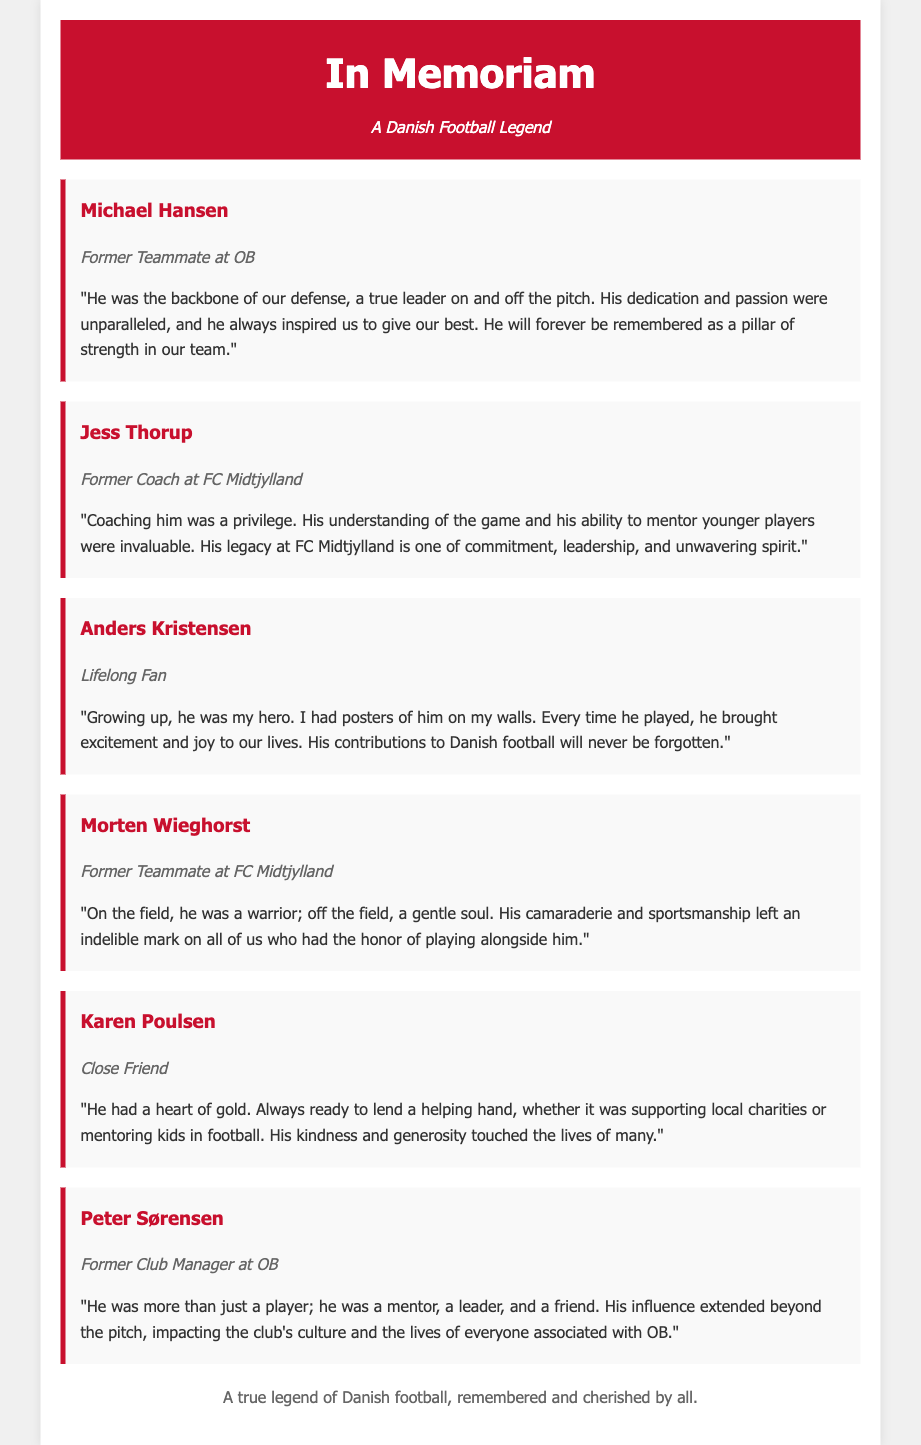What is the title of the document? The title appears in the header of the document and summarizes the tribute being made.
Answer: In Memoriam: A Danish Football Legend Who is quoted as a former teammate at OB? This information is found in the tributes section, identifying the individuals and their associations.
Answer: Michael Hansen What was Jess Thorup's role? The document specifies roles associated with each tribute, indicating who they were to the deceased.
Answer: Former Coach at FC Midtjylland Which friend described the deceased's heart as "of gold"? The document includes personal testimonies that highlight the character of the individual.
Answer: Karen Poulsen How many tributes are featured in the document? The number of tributes is counted in the section where they are presented.
Answer: Six 